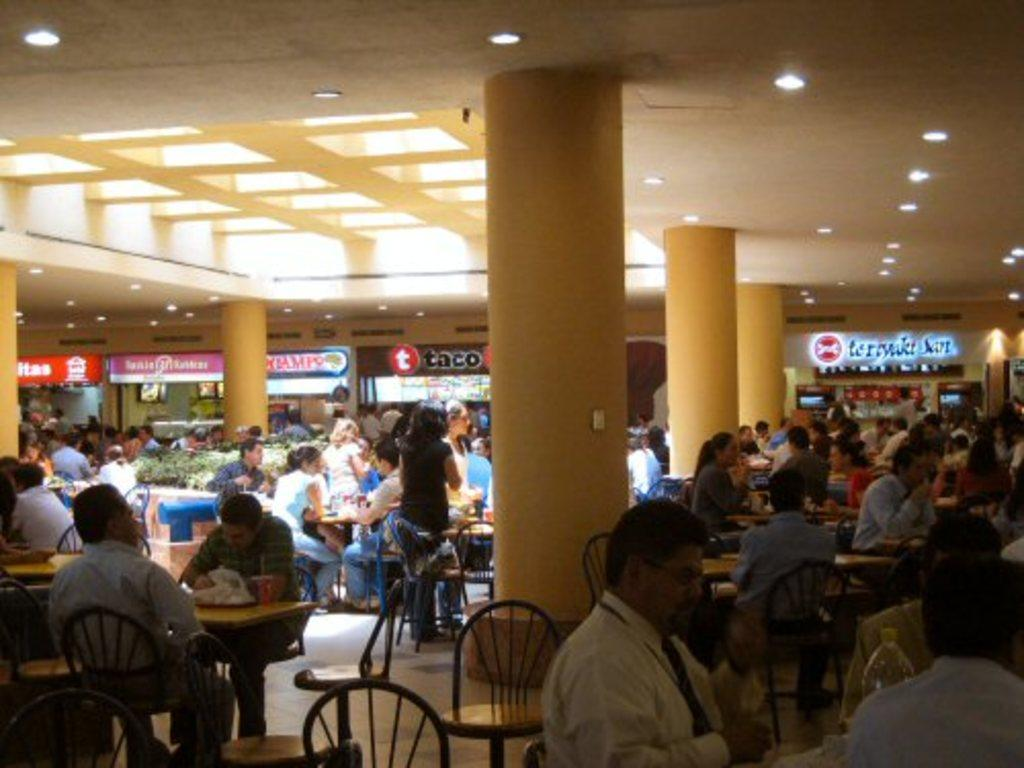How many people are in the image? There are many persons in the image. What are the persons doing in the image? The persons are sitting on chairs. How are the chairs arranged in the image? The chairs are arranged around tables. What type of fog can be seen in the image? There is no fog present in the image; it features many persons sitting on chairs arranged around tables. 